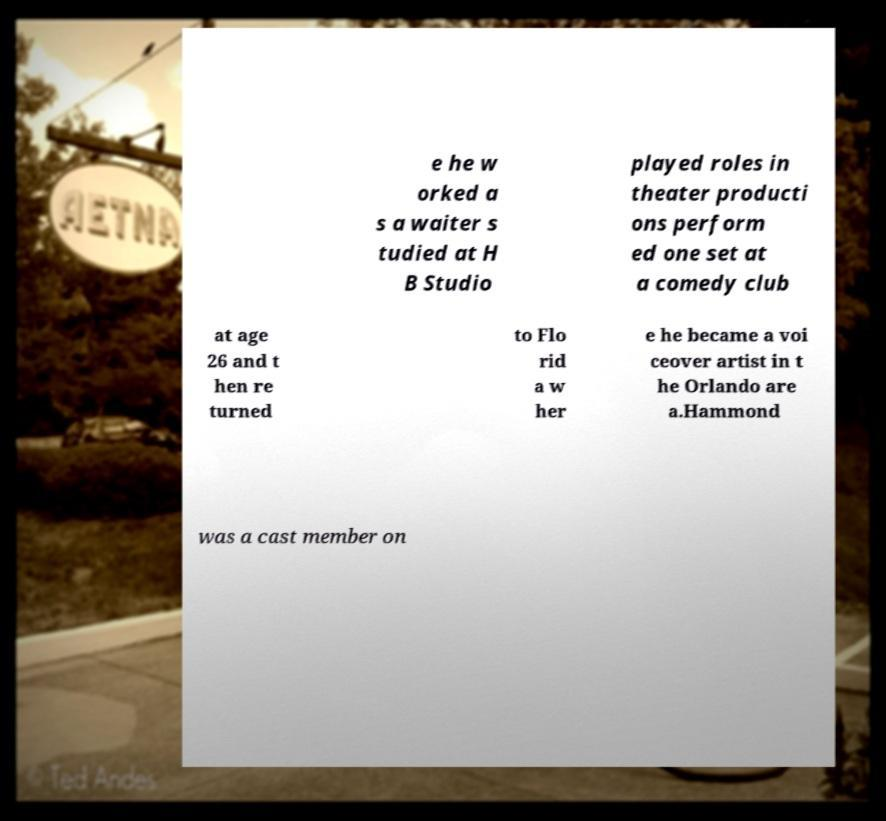There's text embedded in this image that I need extracted. Can you transcribe it verbatim? e he w orked a s a waiter s tudied at H B Studio played roles in theater producti ons perform ed one set at a comedy club at age 26 and t hen re turned to Flo rid a w her e he became a voi ceover artist in t he Orlando are a.Hammond was a cast member on 